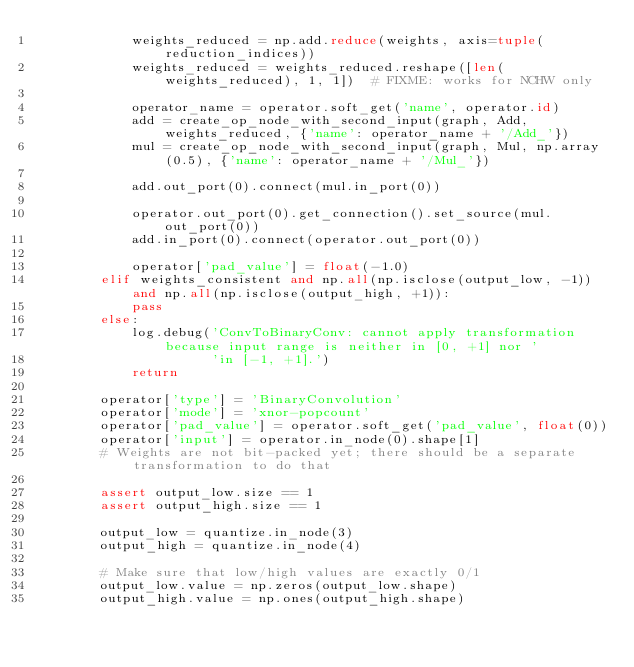<code> <loc_0><loc_0><loc_500><loc_500><_Python_>            weights_reduced = np.add.reduce(weights, axis=tuple(reduction_indices))
            weights_reduced = weights_reduced.reshape([len(weights_reduced), 1, 1])  # FIXME: works for NCHW only

            operator_name = operator.soft_get('name', operator.id)
            add = create_op_node_with_second_input(graph, Add, weights_reduced, {'name': operator_name + '/Add_'})
            mul = create_op_node_with_second_input(graph, Mul, np.array(0.5), {'name': operator_name + '/Mul_'})

            add.out_port(0).connect(mul.in_port(0))

            operator.out_port(0).get_connection().set_source(mul.out_port(0))
            add.in_port(0).connect(operator.out_port(0))

            operator['pad_value'] = float(-1.0)
        elif weights_consistent and np.all(np.isclose(output_low, -1)) and np.all(np.isclose(output_high, +1)):
            pass
        else:
            log.debug('ConvToBinaryConv: cannot apply transformation because input range is neither in [0, +1] nor '
                      'in [-1, +1].')
            return

        operator['type'] = 'BinaryConvolution'
        operator['mode'] = 'xnor-popcount'
        operator['pad_value'] = operator.soft_get('pad_value', float(0))
        operator['input'] = operator.in_node(0).shape[1]
        # Weights are not bit-packed yet; there should be a separate transformation to do that

        assert output_low.size == 1
        assert output_high.size == 1

        output_low = quantize.in_node(3)
        output_high = quantize.in_node(4)

        # Make sure that low/high values are exactly 0/1
        output_low.value = np.zeros(output_low.shape)
        output_high.value = np.ones(output_high.shape)
</code> 